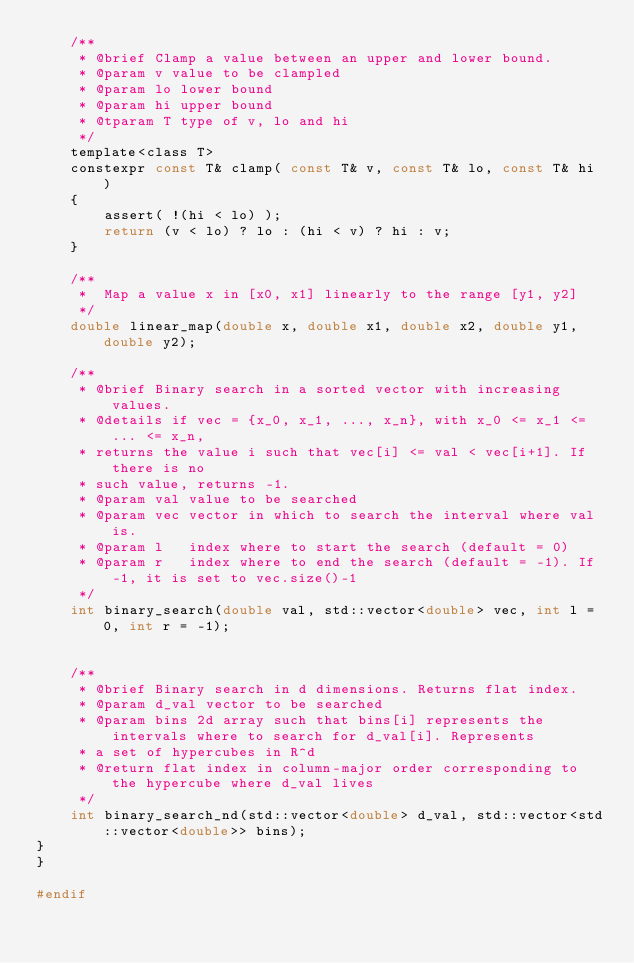<code> <loc_0><loc_0><loc_500><loc_500><_C_>    /**
     * @brief Clamp a value between an upper and lower bound.
     * @param v value to be clampled
     * @param lo lower bound
     * @param hi upper bound
     * @tparam T type of v, lo and hi
     */
    template<class T>
    constexpr const T& clamp( const T& v, const T& lo, const T& hi )
    {
        assert( !(hi < lo) );
        return (v < lo) ? lo : (hi < v) ? hi : v;
    }

    /**
     *  Map a value x in [x0, x1] linearly to the range [y1, y2]
     */
    double linear_map(double x, double x1, double x2, double y1, double y2);

    /**
     * @brief Binary search in a sorted vector with increasing values.
     * @details if vec = {x_0, x_1, ..., x_n}, with x_0 <= x_1 <= ... <= x_n,
     * returns the value i such that vec[i] <= val < vec[i+1]. If there is no
     * such value, returns -1.
     * @param val value to be searched
     * @param vec vector in which to search the interval where val is.
     * @param l   index where to start the search (default = 0)
     * @param r   index where to end the search (default = -1). If -1, it is set to vec.size()-1
     */
    int binary_search(double val, std::vector<double> vec, int l = 0, int r = -1);


    /**
     * @brief Binary search in d dimensions. Returns flat index. 
     * @param d_val vector to be searched
     * @param bins 2d array such that bins[i] represents the intervals where to search for d_val[i]. Represents
     * a set of hypercubes in R^d
     * @return flat index in column-major order corresponding to the hypercube where d_val lives
     */
    int binary_search_nd(std::vector<double> d_val, std::vector<std::vector<double>> bins);
}
}  

#endif
</code> 